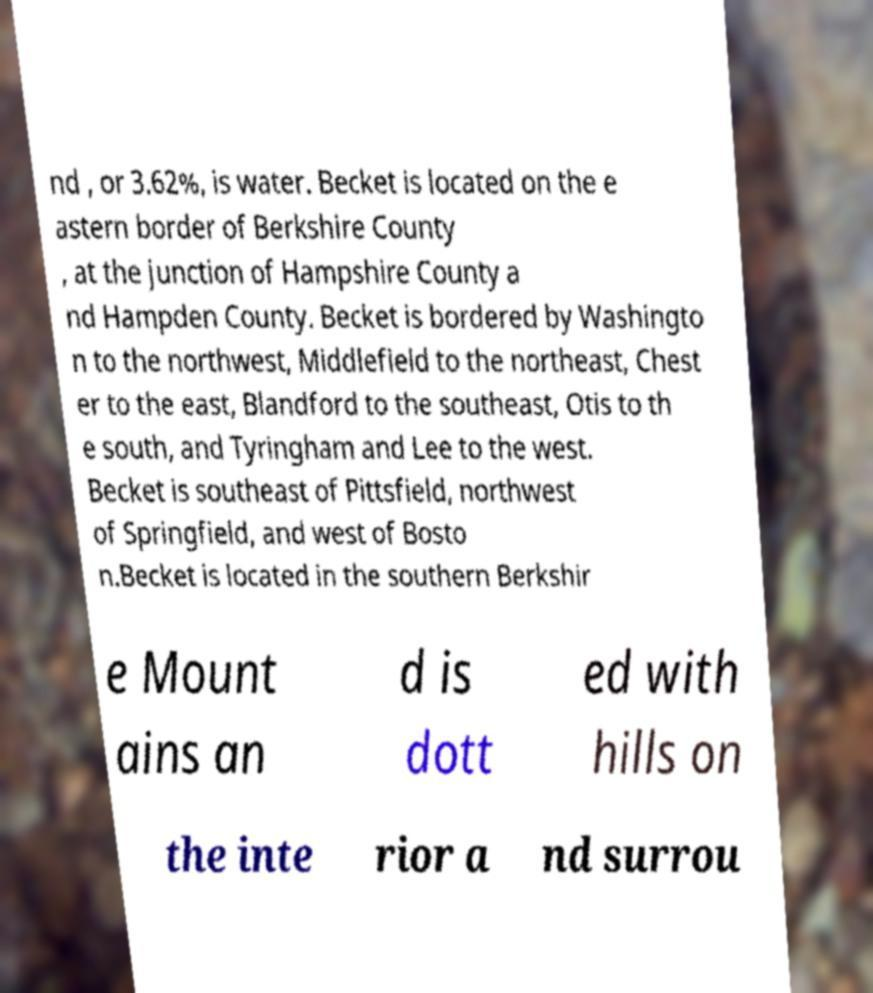Can you read and provide the text displayed in the image?This photo seems to have some interesting text. Can you extract and type it out for me? nd , or 3.62%, is water. Becket is located on the e astern border of Berkshire County , at the junction of Hampshire County a nd Hampden County. Becket is bordered by Washingto n to the northwest, Middlefield to the northeast, Chest er to the east, Blandford to the southeast, Otis to th e south, and Tyringham and Lee to the west. Becket is southeast of Pittsfield, northwest of Springfield, and west of Bosto n.Becket is located in the southern Berkshir e Mount ains an d is dott ed with hills on the inte rior a nd surrou 